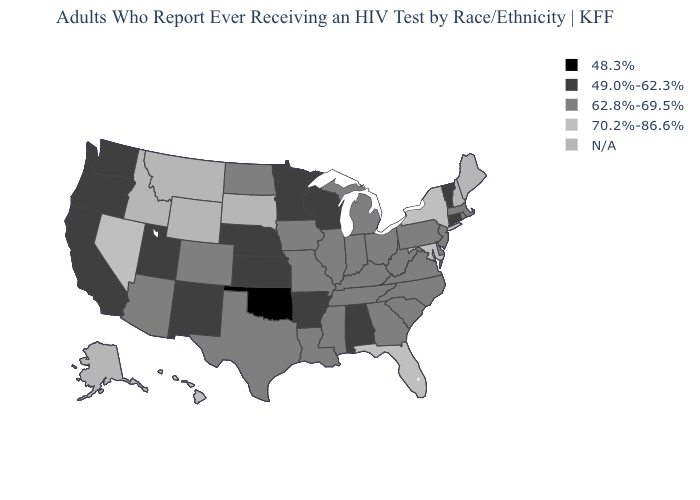Name the states that have a value in the range 62.8%-69.5%?
Concise answer only. Arizona, Colorado, Delaware, Georgia, Illinois, Indiana, Iowa, Kentucky, Louisiana, Massachusetts, Michigan, Mississippi, Missouri, New Jersey, North Carolina, North Dakota, Ohio, Pennsylvania, Rhode Island, South Carolina, Tennessee, Texas, Virginia, West Virginia. Name the states that have a value in the range 48.3%?
Write a very short answer. Oklahoma. What is the lowest value in the USA?
Write a very short answer. 48.3%. What is the highest value in the USA?
Give a very brief answer. 70.2%-86.6%. Name the states that have a value in the range 49.0%-62.3%?
Give a very brief answer. Alabama, Arkansas, California, Connecticut, Kansas, Minnesota, Nebraska, New Mexico, Oregon, Utah, Vermont, Washington, Wisconsin. Name the states that have a value in the range N/A?
Keep it brief. Alaska, Idaho, Maine, Montana, New Hampshire, South Dakota, Wyoming. How many symbols are there in the legend?
Keep it brief. 5. Which states have the lowest value in the MidWest?
Write a very short answer. Kansas, Minnesota, Nebraska, Wisconsin. What is the lowest value in the West?
Answer briefly. 49.0%-62.3%. Does the map have missing data?
Quick response, please. Yes. Among the states that border Connecticut , does New York have the highest value?
Keep it brief. Yes. How many symbols are there in the legend?
Answer briefly. 5. What is the highest value in the South ?
Keep it brief. 70.2%-86.6%. Does Florida have the lowest value in the USA?
Write a very short answer. No. What is the highest value in the USA?
Keep it brief. 70.2%-86.6%. 